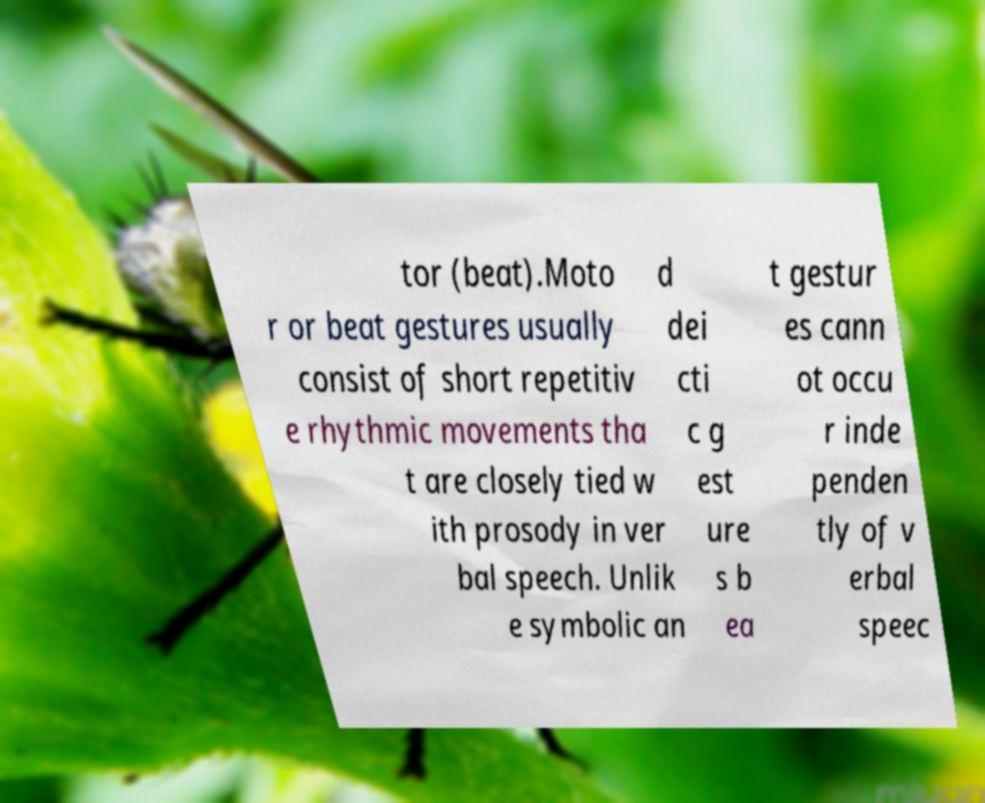For documentation purposes, I need the text within this image transcribed. Could you provide that? tor (beat).Moto r or beat gestures usually consist of short repetitiv e rhythmic movements tha t are closely tied w ith prosody in ver bal speech. Unlik e symbolic an d dei cti c g est ure s b ea t gestur es cann ot occu r inde penden tly of v erbal speec 